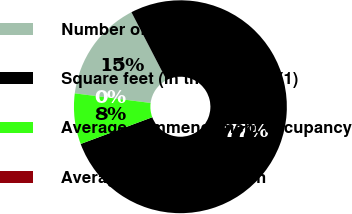Convert chart to OTSL. <chart><loc_0><loc_0><loc_500><loc_500><pie_chart><fcel>Number of properties<fcel>Square feet (in thousands) (1)<fcel>Average commencement occupancy<fcel>Average rental rate - cash<nl><fcel>15.39%<fcel>76.92%<fcel>7.69%<fcel>0.0%<nl></chart> 